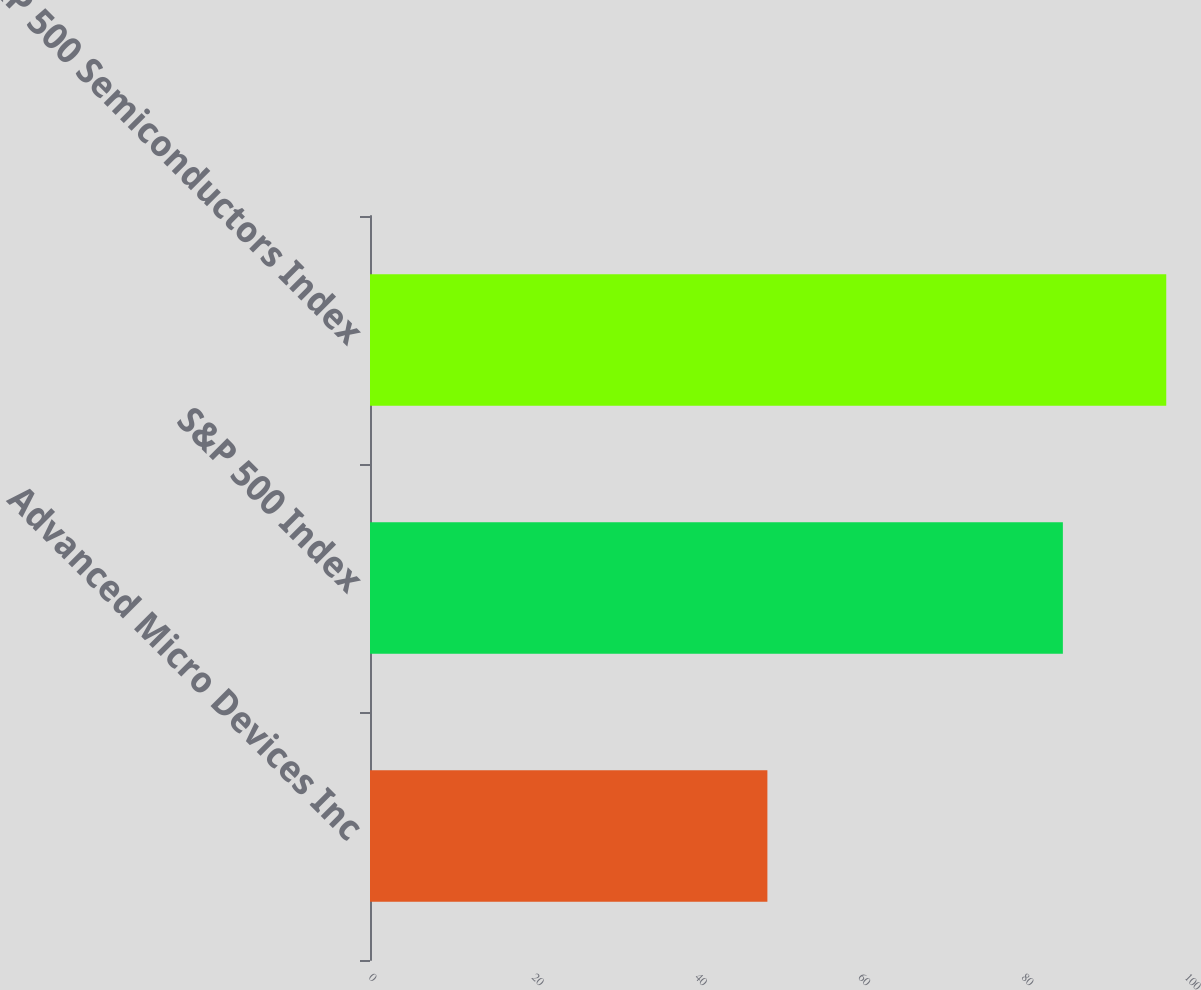Convert chart to OTSL. <chart><loc_0><loc_0><loc_500><loc_500><bar_chart><fcel>Advanced Micro Devices Inc<fcel>S&P 500 Index<fcel>S&P 500 Semiconductors Index<nl><fcel>48.7<fcel>84.91<fcel>97.58<nl></chart> 